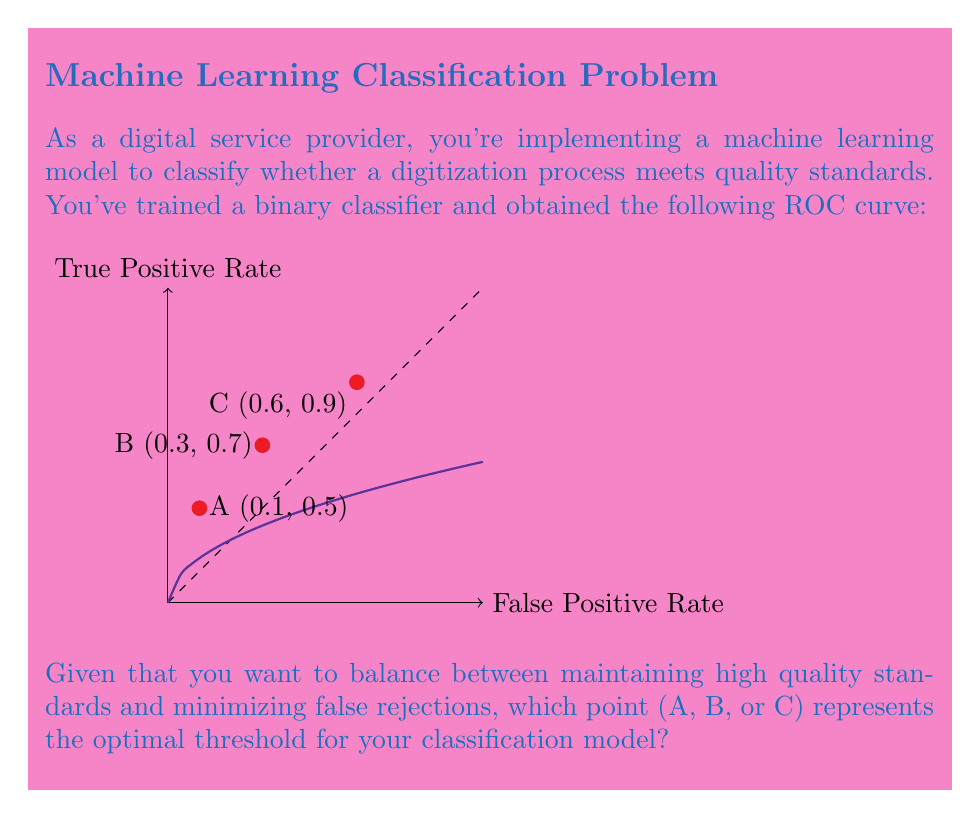Provide a solution to this math problem. To determine the optimal threshold using the ROC curve, we need to consider the trade-off between the True Positive Rate (TPR) and False Positive Rate (FPR). The optimal point is often the one closest to the top-left corner of the ROC plot, which represents perfect classification (100% TPR, 0% FPR).

Let's analyze each point:

1. Calculate the distance from each point to the top-left corner (0,1) using the Euclidean distance formula:
   $$d = \sqrt{(FPR - 0)^2 + (TPR - 1)^2}$$

2. For point A (0.1, 0.5):
   $$d_A = \sqrt{(0.1 - 0)^2 + (0.5 - 1)^2} = \sqrt{0.01 + 0.25} = \sqrt{0.26} \approx 0.51$$

3. For point B (0.3, 0.7):
   $$d_B = \sqrt{(0.3 - 0)^2 + (0.7 - 1)^2} = \sqrt{0.09 + 0.09} = \sqrt{0.18} \approx 0.42$$

4. For point C (0.6, 0.9):
   $$d_C = \sqrt{(0.6 - 0)^2 + (0.9 - 1)^2} = \sqrt{0.36 + 0.01} = \sqrt{0.37} \approx 0.61$$

5. Compare the distances:
   $d_B < d_A < d_C$

Therefore, point B has the shortest distance to the top-left corner and represents the best balance between TPR and FPR for maintaining high quality standards while minimizing false rejections.
Answer: B (0.3, 0.7) 